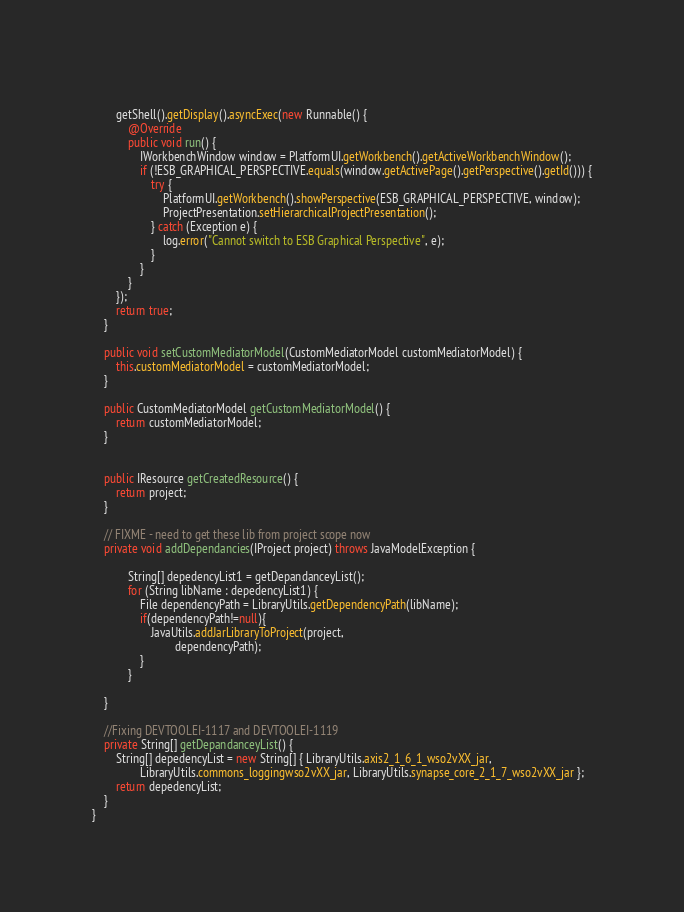Convert code to text. <code><loc_0><loc_0><loc_500><loc_500><_Java_>	    
		getShell().getDisplay().asyncExec(new Runnable() {
			@Override
			public void run() {
				IWorkbenchWindow window = PlatformUI.getWorkbench().getActiveWorkbenchWindow();
				if (!ESB_GRAPHICAL_PERSPECTIVE.equals(window.getActivePage().getPerspective().getId())) {
					try {
						PlatformUI.getWorkbench().showPerspective(ESB_GRAPHICAL_PERSPECTIVE, window);
						ProjectPresentation.setHierarchicalProjectPresentation();
					} catch (Exception e) {
						log.error("Cannot switch to ESB Graphical Perspective", e);
					}
				}
			}
		});
		return true;
	}

	public void setCustomMediatorModel(CustomMediatorModel customMediatorModel) {
		this.customMediatorModel = customMediatorModel;
	}

	public CustomMediatorModel getCustomMediatorModel() {
		return customMediatorModel;
	}

	
	public IResource getCreatedResource() {
		return project;
	}
	
	// FIXME - need to get these lib from project scope now
	private void addDependancies(IProject project) throws JavaModelException {
 
			String[] depedencyList1 = getDepandanceyList();
			for (String libName : depedencyList1) {
				File dependencyPath = LibraryUtils.getDependencyPath(libName);
				if(dependencyPath!=null){
					JavaUtils.addJarLibraryToProject(project,
							dependencyPath);
				}
			}
		 
	}
	
	//Fixing DEVTOOLEI-1117 and DEVTOOLEI-1119
	private String[] getDepandanceyList() {
		String[] depedencyList = new String[] { LibraryUtils.axis2_1_6_1_wso2vXX_jar,
				LibraryUtils.commons_loggingwso2vXX_jar, LibraryUtils.synapse_core_2_1_7_wso2vXX_jar };
		return depedencyList;
	}
}
</code> 